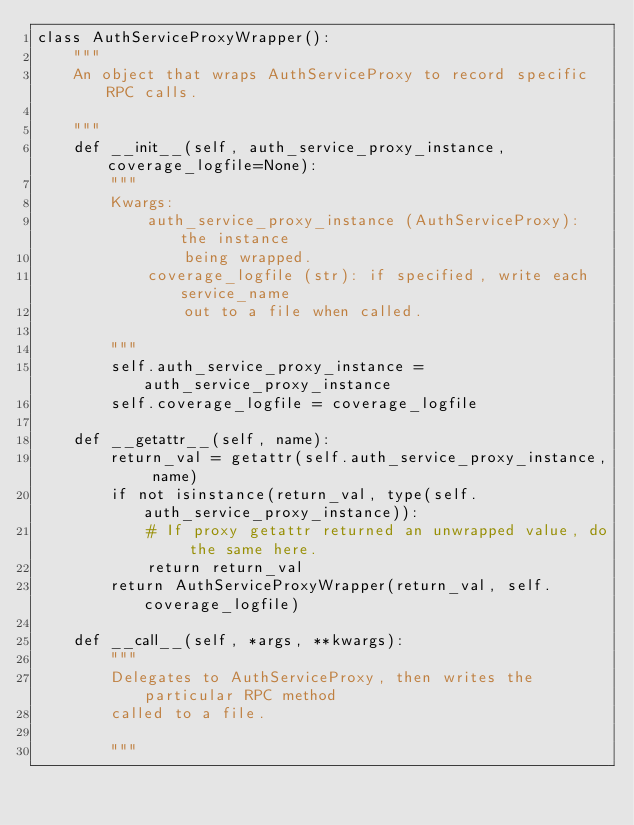Convert code to text. <code><loc_0><loc_0><loc_500><loc_500><_Python_>class AuthServiceProxyWrapper():
    """
    An object that wraps AuthServiceProxy to record specific RPC calls.

    """
    def __init__(self, auth_service_proxy_instance, coverage_logfile=None):
        """
        Kwargs:
            auth_service_proxy_instance (AuthServiceProxy): the instance
                being wrapped.
            coverage_logfile (str): if specified, write each service_name
                out to a file when called.

        """
        self.auth_service_proxy_instance = auth_service_proxy_instance
        self.coverage_logfile = coverage_logfile

    def __getattr__(self, name):
        return_val = getattr(self.auth_service_proxy_instance, name)
        if not isinstance(return_val, type(self.auth_service_proxy_instance)):
            # If proxy getattr returned an unwrapped value, do the same here.
            return return_val
        return AuthServiceProxyWrapper(return_val, self.coverage_logfile)

    def __call__(self, *args, **kwargs):
        """
        Delegates to AuthServiceProxy, then writes the particular RPC method
        called to a file.

        """</code> 